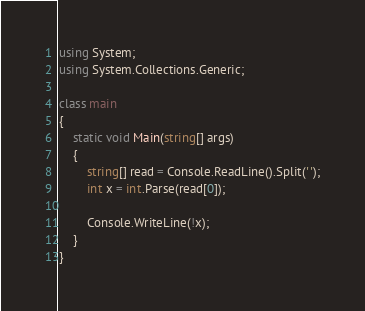Convert code to text. <code><loc_0><loc_0><loc_500><loc_500><_C#_>using System;
using System.Collections.Generic;

class main
{
    static void Main(string[] args)
    {
        string[] read = Console.ReadLine().Split(' ');
        int x = int.Parse(read[0]);
		
		Console.WriteLine(!x);
	}
}

</code> 